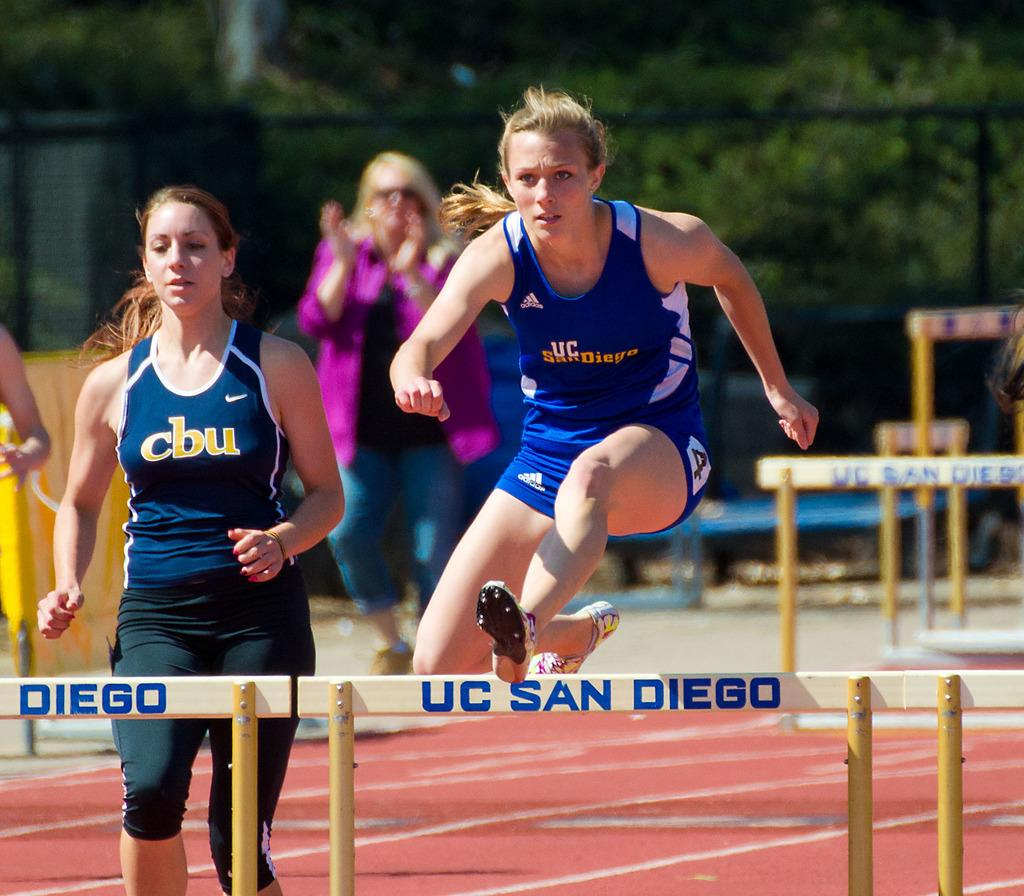<image>
Describe the image concisely. A man jumps over a hurdle at the University of California San Diego. 